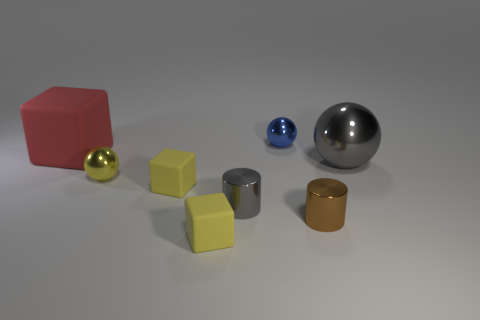Is there any other thing that has the same color as the big block?
Provide a short and direct response. No. Is there a small metallic cylinder of the same color as the big ball?
Ensure brevity in your answer.  Yes. Are there the same number of small blue things in front of the blue object and brown cylinders that are to the right of the small brown cylinder?
Your answer should be compact. Yes. There is a blue object; is it the same shape as the object in front of the brown thing?
Give a very brief answer. No. How many other objects are there of the same material as the tiny yellow sphere?
Your answer should be compact. 4. Are there any tiny shiny objects on the left side of the gray shiny cylinder?
Provide a succinct answer. Yes. Does the blue thing have the same size as the gray shiny thing in front of the yellow metal ball?
Make the answer very short. Yes. The small metallic ball in front of the big thing to the right of the big cube is what color?
Provide a succinct answer. Yellow. Do the gray metallic sphere and the red cube have the same size?
Provide a succinct answer. Yes. There is a shiny object that is both right of the tiny blue metallic object and behind the brown thing; what is its color?
Provide a succinct answer. Gray. 